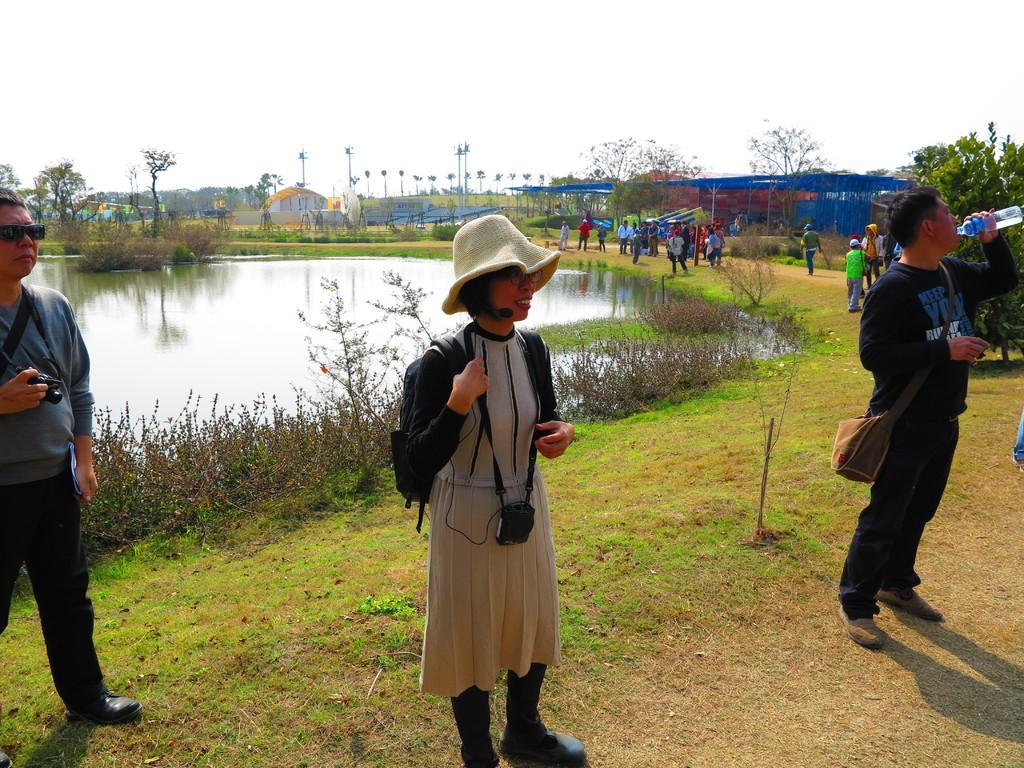How would you summarize this image in a sentence or two? This picture is clicked outside. On the right we can see the group of people seems to be standing on the ground, we can see the green grass, plants and a water body. In the background there is a sky, tents, trees and poles. 